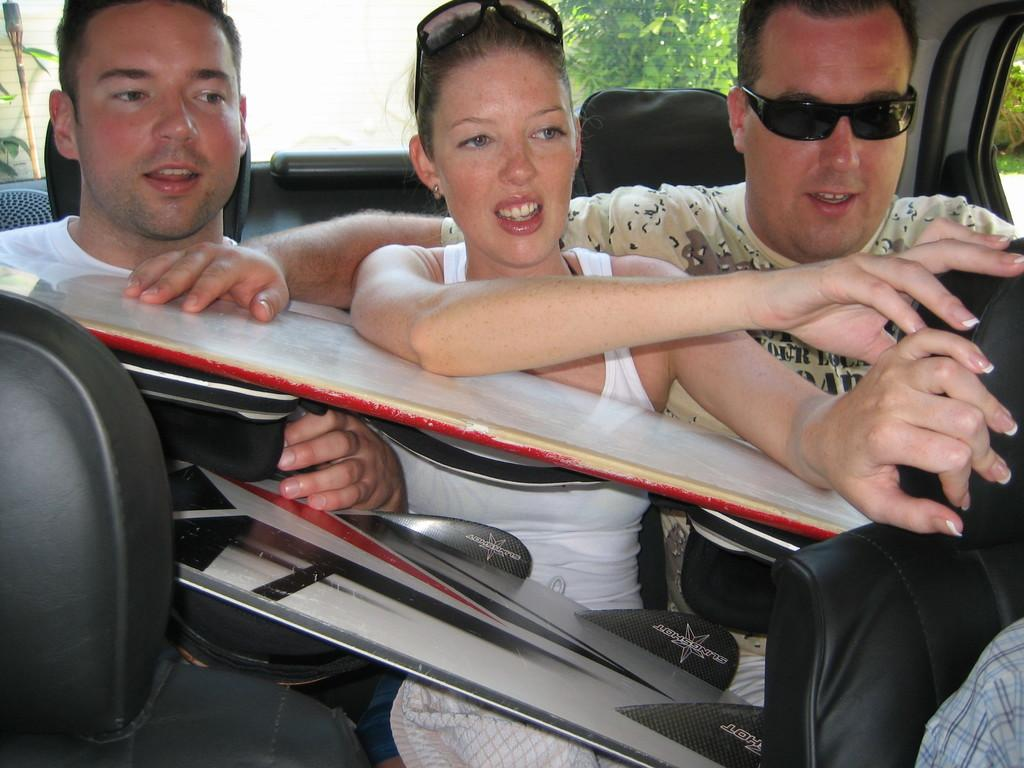Where was the image taken? The image was taken inside a car. How many people are in the car? There are three persons in the car. What are the people holding? The persons are holding something, but we cannot determine what it is from the image. Who is sitting in the middle of the car? There is a lady sitting in the middle. What can be seen in the background of the image? There are trees and the sky visible in the background of the image. What type of flesh can be seen in the image? There is no flesh visible in the image; it is taken inside a car with three people. Are there any slaves depicted in the image? There is no mention or depiction of slavery in the image. 